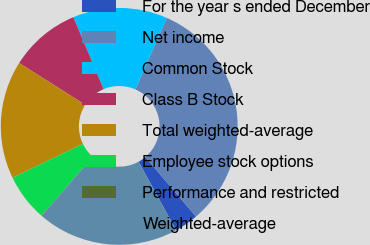<chart> <loc_0><loc_0><loc_500><loc_500><pie_chart><fcel>For the year s ended December<fcel>Net income<fcel>Common Stock<fcel>Class B Stock<fcel>Total weighted-average<fcel>Employee stock options<fcel>Performance and restricted<fcel>Weighted-average<nl><fcel>3.25%<fcel>32.2%<fcel>12.9%<fcel>9.69%<fcel>16.12%<fcel>6.47%<fcel>0.03%<fcel>19.34%<nl></chart> 